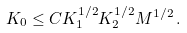Convert formula to latex. <formula><loc_0><loc_0><loc_500><loc_500>K _ { 0 } \leq C K _ { 1 } ^ { 1 / 2 } K _ { 2 } ^ { 1 / 2 } M ^ { 1 / 2 } \, .</formula> 